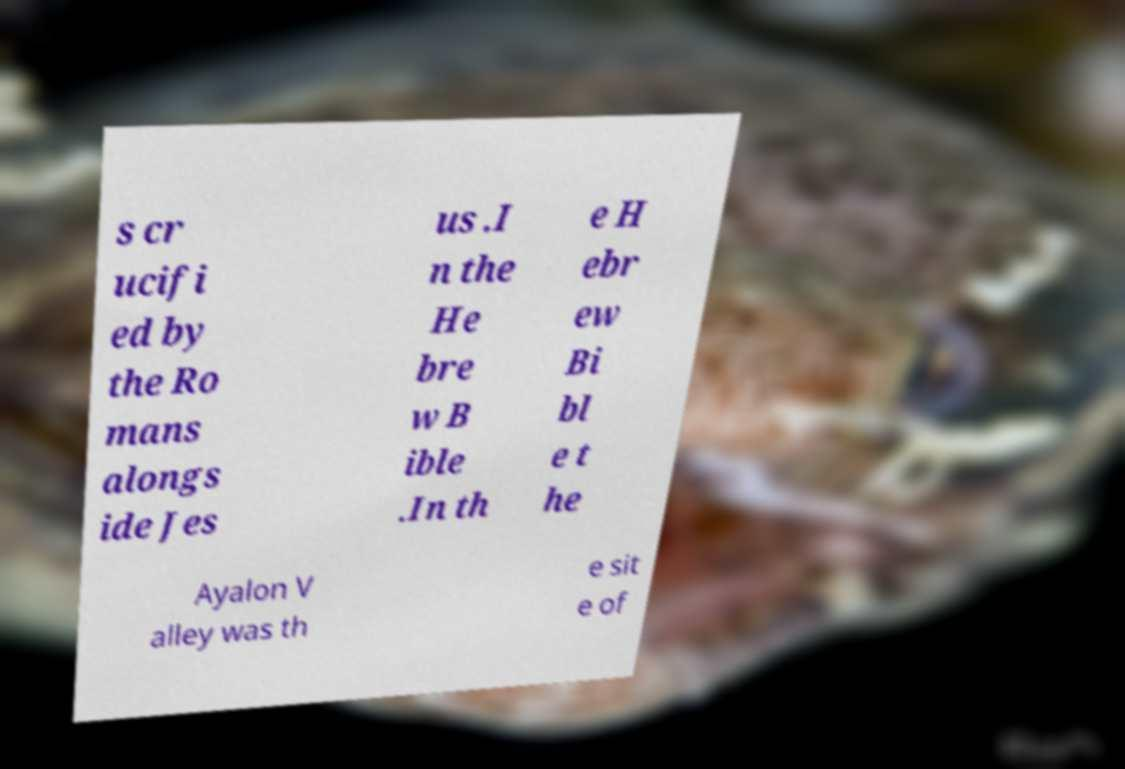Please identify and transcribe the text found in this image. s cr ucifi ed by the Ro mans alongs ide Jes us .I n the He bre w B ible .In th e H ebr ew Bi bl e t he Ayalon V alley was th e sit e of 